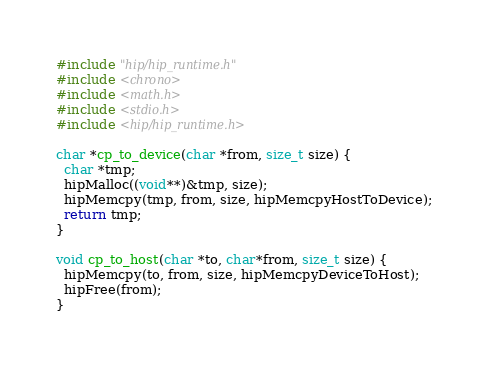Convert code to text. <code><loc_0><loc_0><loc_500><loc_500><_Cuda_>#include "hip/hip_runtime.h"
#include <chrono>
#include <math.h>
#include <stdio.h>
#include <hip/hip_runtime.h>

char *cp_to_device(char *from, size_t size) {
  char *tmp;
  hipMalloc((void**)&tmp, size);
  hipMemcpy(tmp, from, size, hipMemcpyHostToDevice);
  return tmp;
}

void cp_to_host(char *to, char*from, size_t size) {
  hipMemcpy(to, from, size, hipMemcpyDeviceToHost);
  hipFree(from);
}</code> 